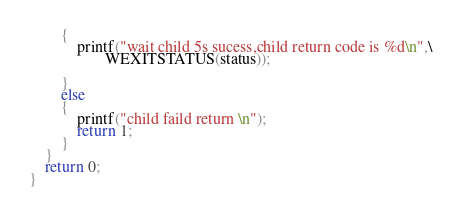<code> <loc_0><loc_0><loc_500><loc_500><_C_>        {
            printf("wait child 5s sucess,child return code is %d\n",\
                   WEXITSTATUS(status));

        }
        else
        {
            printf("child faild return \n");
            return 1;
        }
    }
    return 0;
}
</code> 